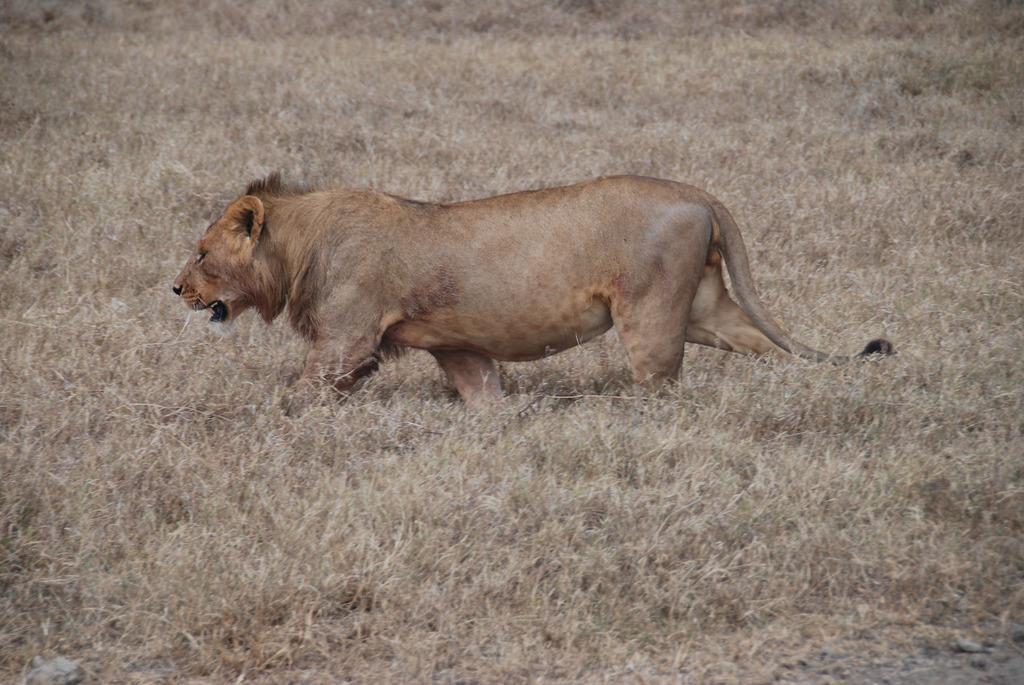Can you describe this image briefly? This is an outside view. Here I can see the grass on the ground. In the middle of the image there is a lion walking towards the left side. 